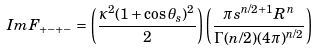<formula> <loc_0><loc_0><loc_500><loc_500>I m F _ { + - + - } = \left ( \frac { \kappa ^ { 2 } ( 1 + \cos \theta _ { s } ) ^ { 2 } } { 2 } \right ) \left ( \frac { \pi s ^ { n / 2 + 1 } R ^ { n } } { \Gamma ( n / 2 ) ( 4 \pi ) ^ { n / 2 } } \right )</formula> 